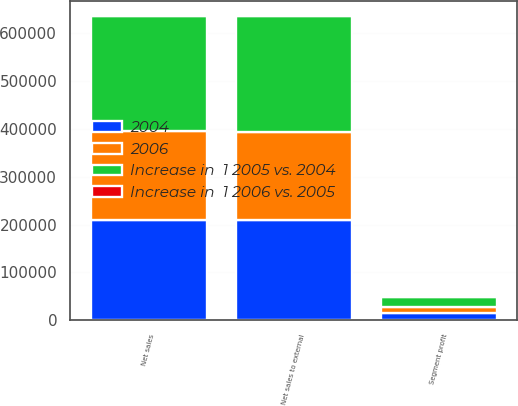<chart> <loc_0><loc_0><loc_500><loc_500><stacked_bar_chart><ecel><fcel>Net sales<fcel>Net sales to external<fcel>Segment profit<nl><fcel>Increase in  1 2005 vs. 2004<fcel>240869<fcel>240869<fcel>21412<nl><fcel>2004<fcel>209454<fcel>208895<fcel>14745<nl><fcel>2006<fcel>185325<fcel>185325<fcel>12882<nl><fcel>Increase in  1 2006 vs. 2005<fcel>15<fcel>15<fcel>45<nl></chart> 